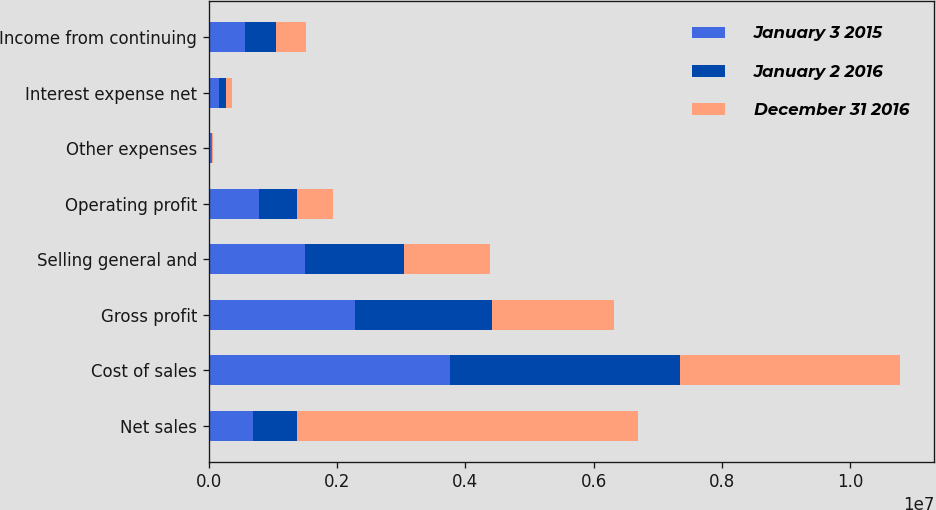<chart> <loc_0><loc_0><loc_500><loc_500><stacked_bar_chart><ecel><fcel>Net sales<fcel>Cost of sales<fcel>Gross profit<fcel>Selling general and<fcel>Operating profit<fcel>Other expenses<fcel>Interest expense net<fcel>Income from continuing<nl><fcel>January 3 2015<fcel>685384<fcel>3.75215e+06<fcel>2.27605e+06<fcel>1.5004e+06<fcel>775649<fcel>51758<fcel>152692<fcel>571199<nl><fcel>January 2 2016<fcel>685384<fcel>3.59522e+06<fcel>2.13633e+06<fcel>1.54121e+06<fcel>595118<fcel>3210<fcel>118035<fcel>473873<nl><fcel>December 31 2016<fcel>5.32475e+06<fcel>3.42034e+06<fcel>1.90441e+06<fcel>1.34045e+06<fcel>563954<fcel>2599<fcel>96387<fcel>464968<nl></chart> 